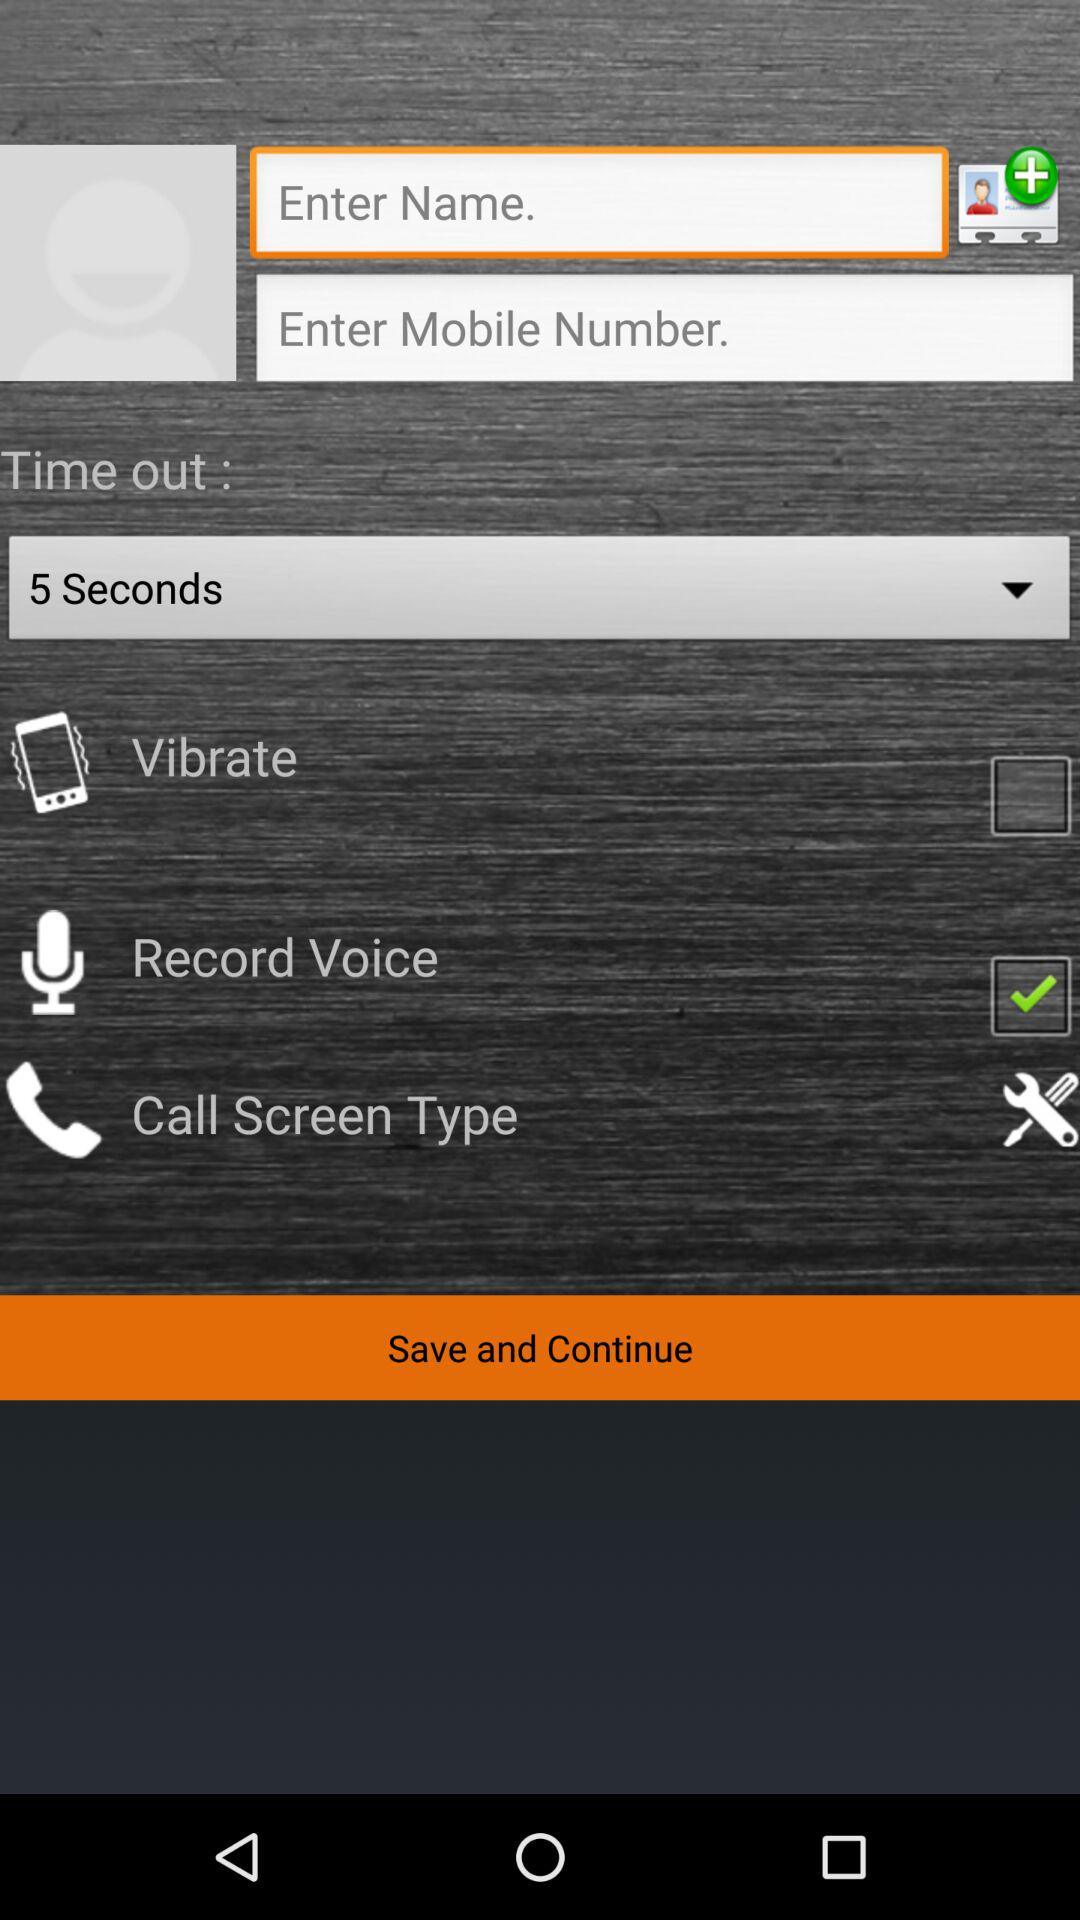What's the status of "Record Voice"? The status of "Record Voice" is "on". 